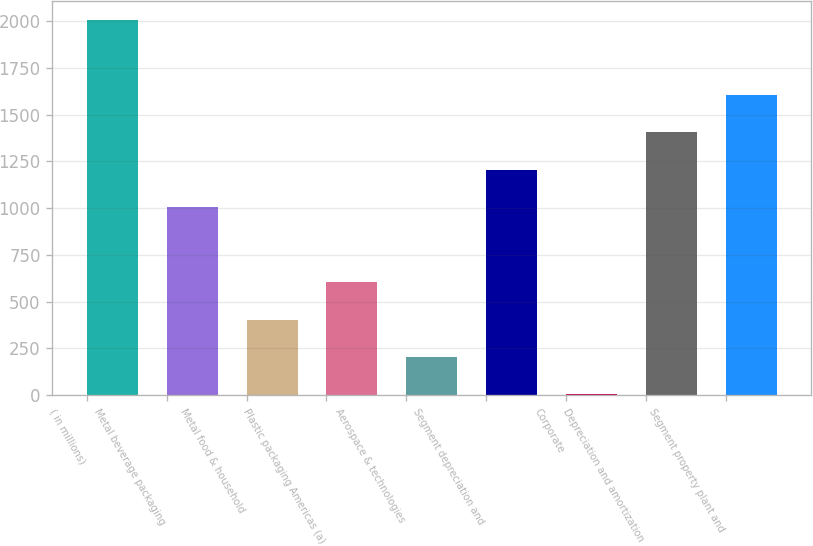Convert chart. <chart><loc_0><loc_0><loc_500><loc_500><bar_chart><fcel>( in millions)<fcel>Metal beverage packaging<fcel>Metal food & household<fcel>Plastic packaging Americas (a)<fcel>Aerospace & technologies<fcel>Segment depreciation and<fcel>Corporate<fcel>Depreciation and amortization<fcel>Segment property plant and<nl><fcel>2007<fcel>1005.2<fcel>404.12<fcel>604.48<fcel>203.76<fcel>1205.56<fcel>3.4<fcel>1405.92<fcel>1606.28<nl></chart> 